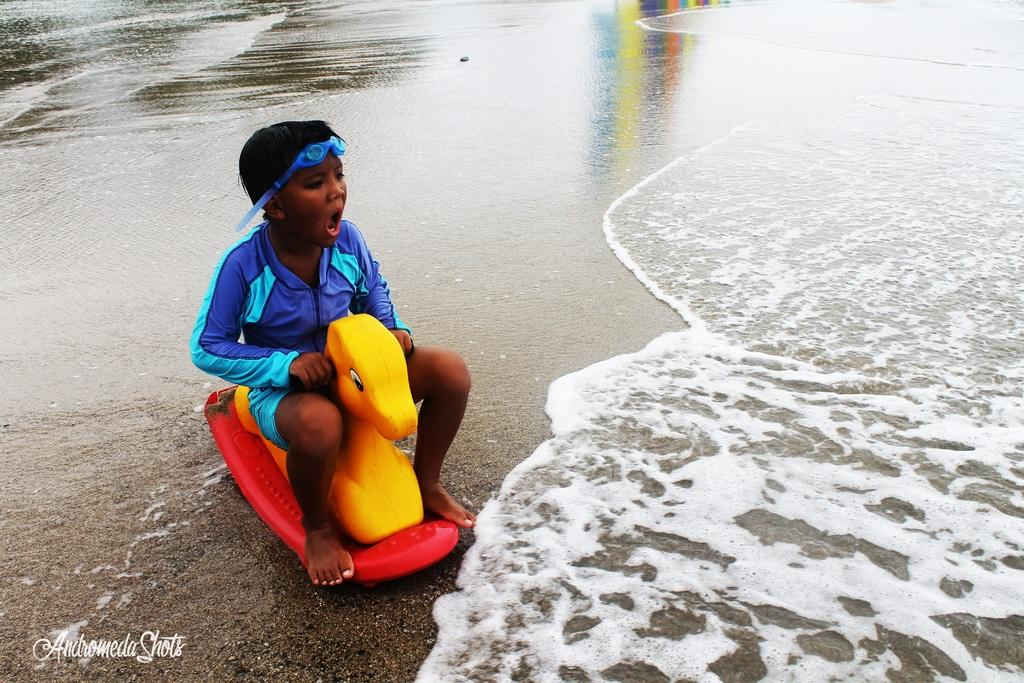What is the main subject of the image? The main subject of the image is a boy. What is the boy doing in the image? The boy is sitting on a toy. What can be seen in the background of the image? There is a sea visible in the image. Can you see a bridge in the image? There is no bridge visible in the image. What type of card is the boy holding in the image? There is no card present in the image. 